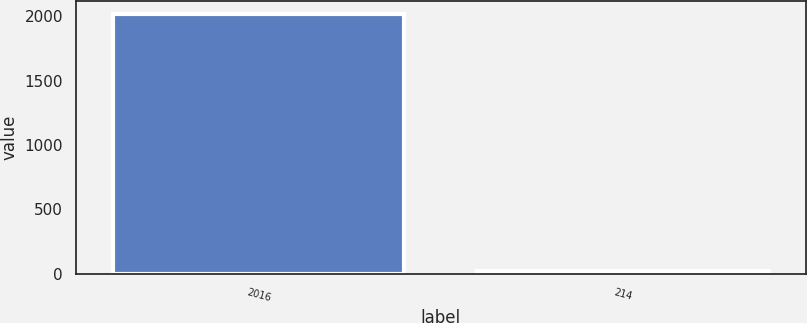Convert chart to OTSL. <chart><loc_0><loc_0><loc_500><loc_500><bar_chart><fcel>2016<fcel>214<nl><fcel>2015<fcel>21.7<nl></chart> 